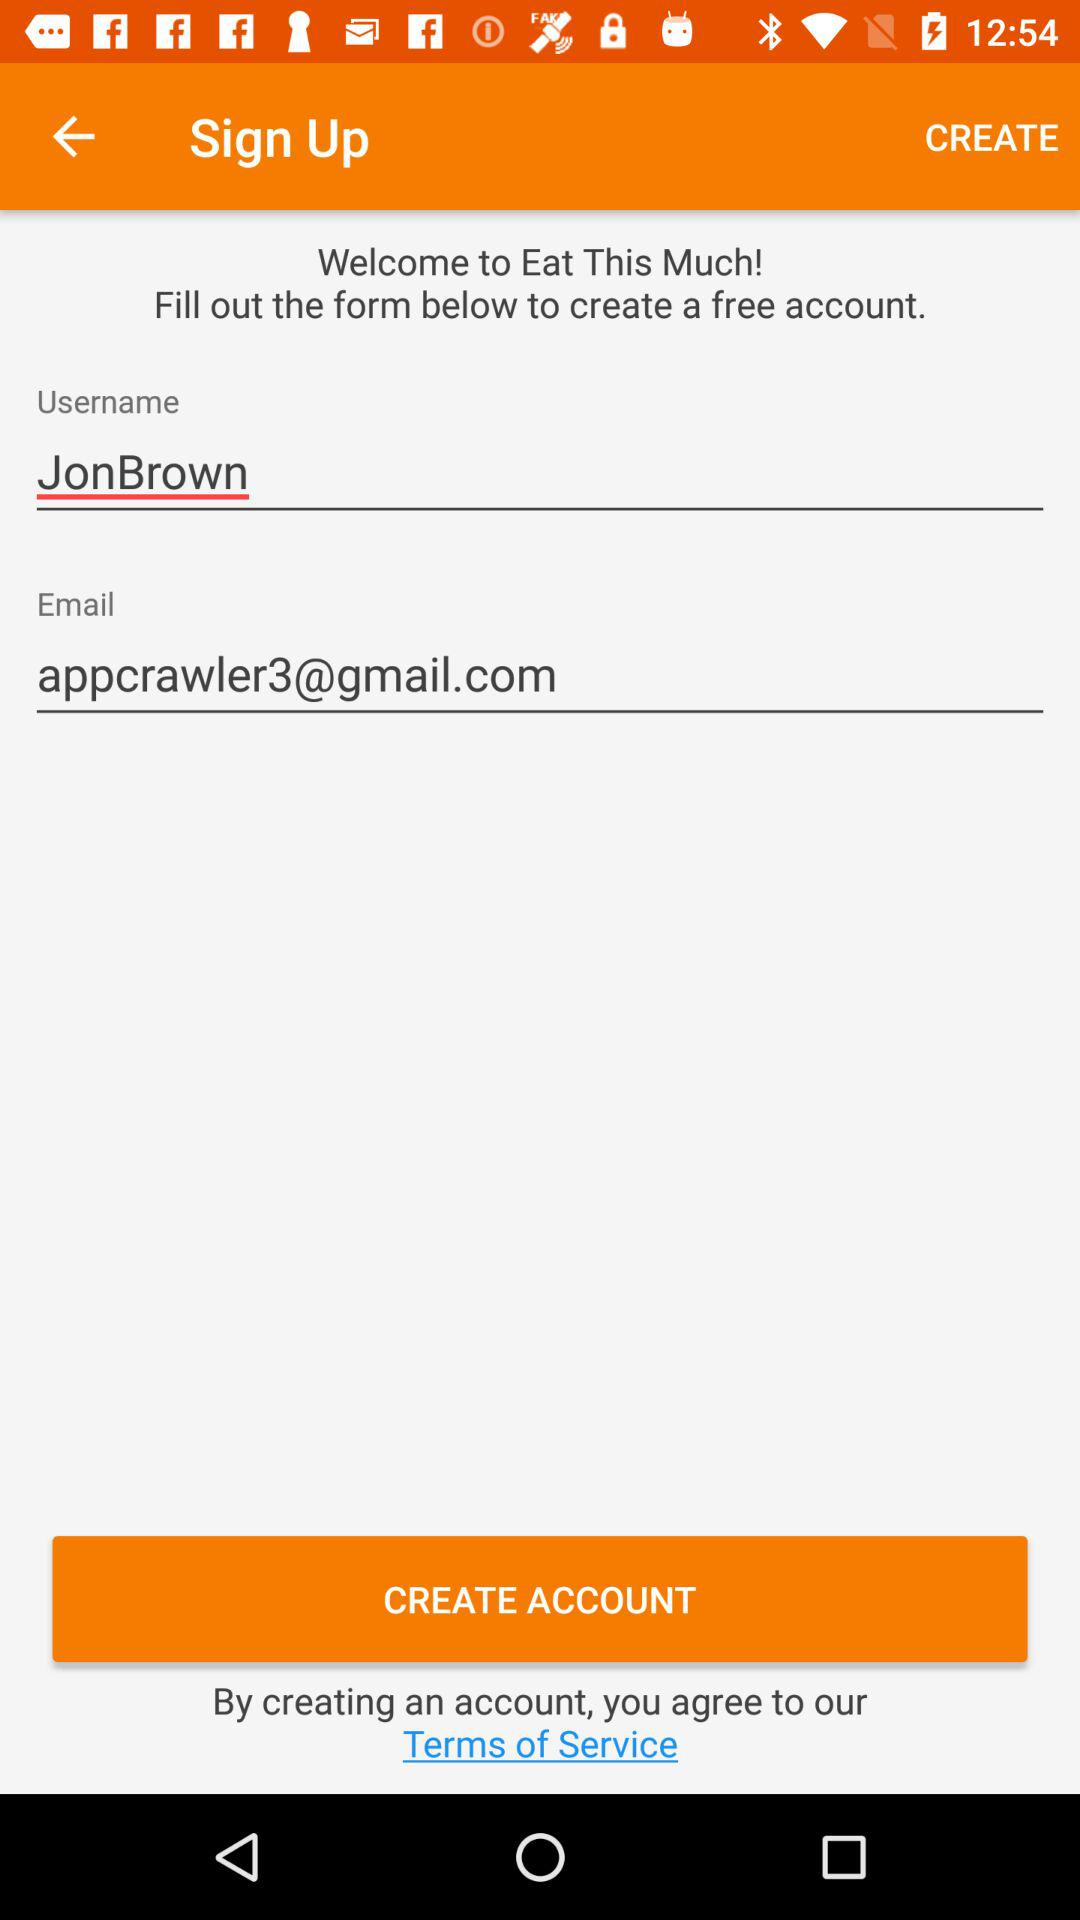What is the name of the user? The name of the user is Jon Brown. 